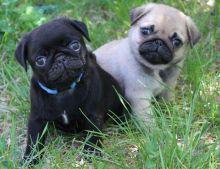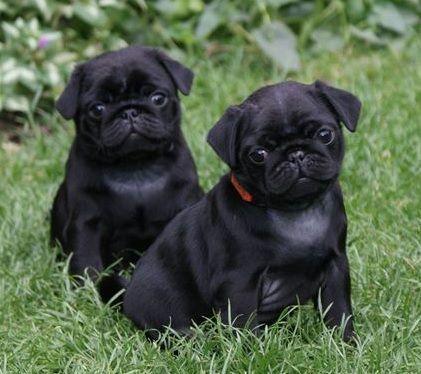The first image is the image on the left, the second image is the image on the right. Assess this claim about the two images: "All the images show pugs that are tan.". Correct or not? Answer yes or no. No. The first image is the image on the left, the second image is the image on the right. Given the left and right images, does the statement "There is a toy present with two dogs." hold true? Answer yes or no. No. 